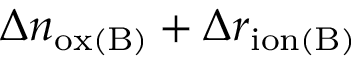<formula> <loc_0><loc_0><loc_500><loc_500>\Delta n _ { o x ( B ) } + \Delta r _ { i o n ( B ) }</formula> 